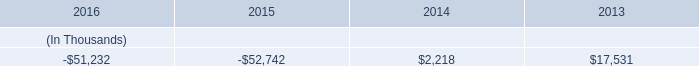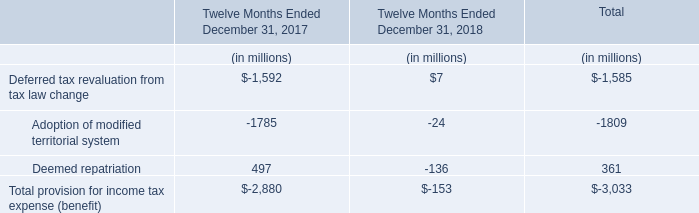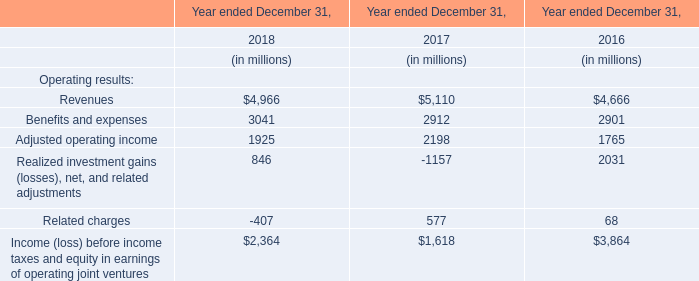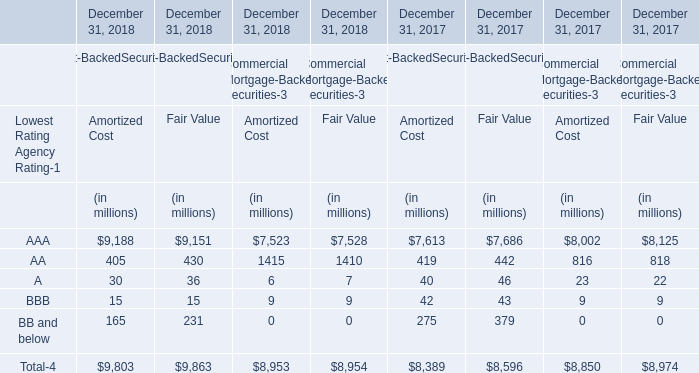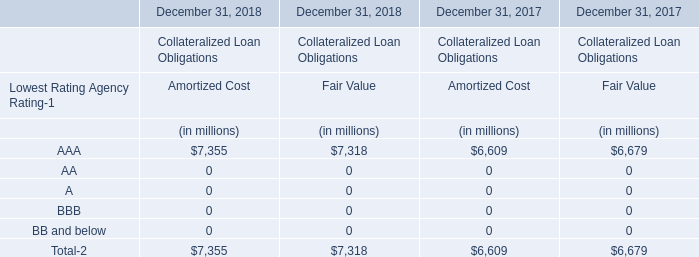What's the total amount of the Fair Value in the years where AAA greater than 0? (in million) 
Computations: (((9863 + 8954) + 8596) + 8974)
Answer: 36387.0. 